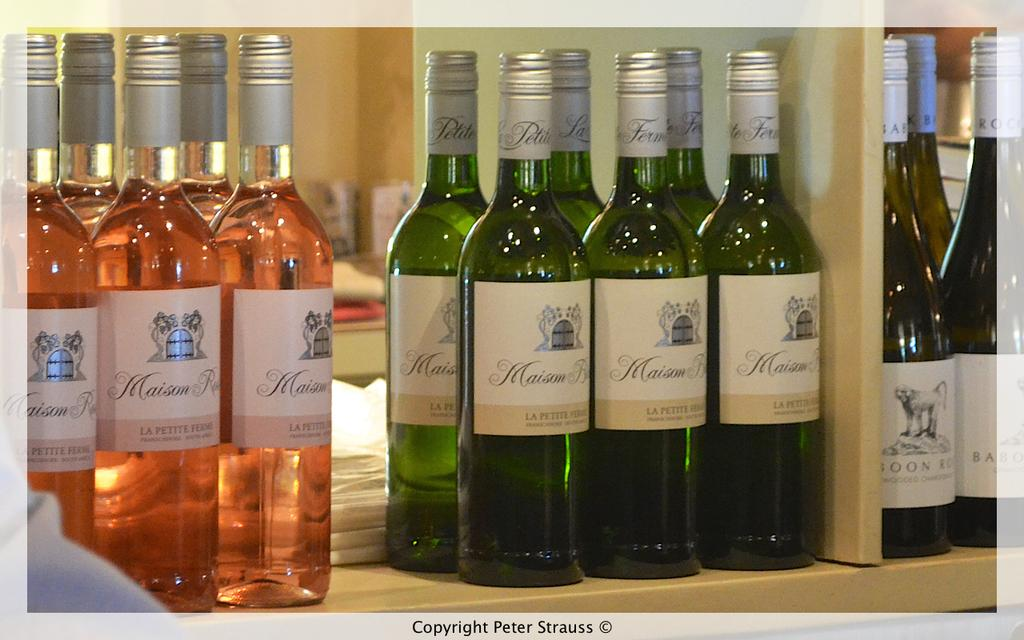<image>
Write a terse but informative summary of the picture. Wine Bottles on a shelf that contain the text Maison on the label. 